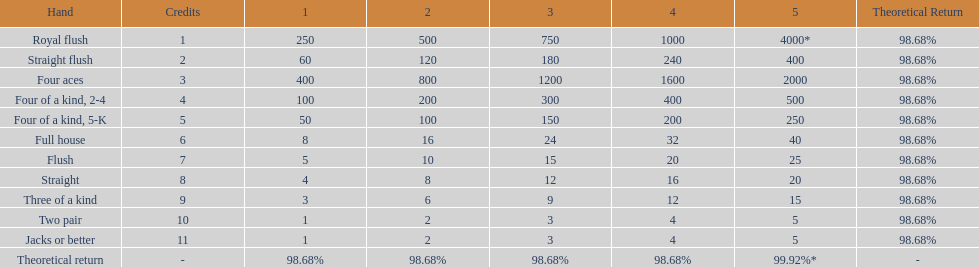Which hand is the top hand in the card game super aces? Royal flush. 